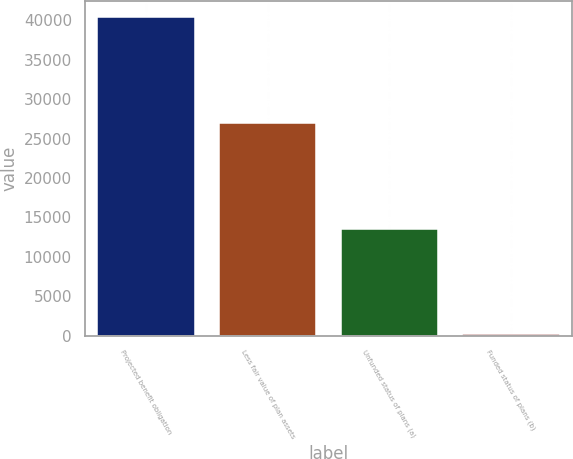Convert chart. <chart><loc_0><loc_0><loc_500><loc_500><bar_chart><fcel>Projected benefit obligation<fcel>Less fair value of plan assets<fcel>Unfunded status of plans (a)<fcel>Funded status of plans (b)<nl><fcel>40478<fcel>26976<fcel>13502<fcel>178<nl></chart> 